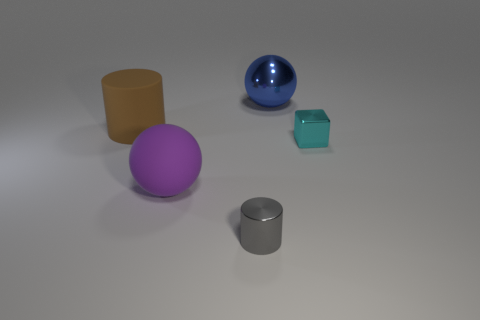Subtract all purple blocks. Subtract all brown cylinders. How many blocks are left? 1 Add 3 tiny metallic cylinders. How many objects exist? 8 Subtract all spheres. How many objects are left? 3 Subtract 0 green cylinders. How many objects are left? 5 Subtract all large brown metal cylinders. Subtract all gray things. How many objects are left? 4 Add 2 purple rubber spheres. How many purple rubber spheres are left? 3 Add 3 tiny gray objects. How many tiny gray objects exist? 4 